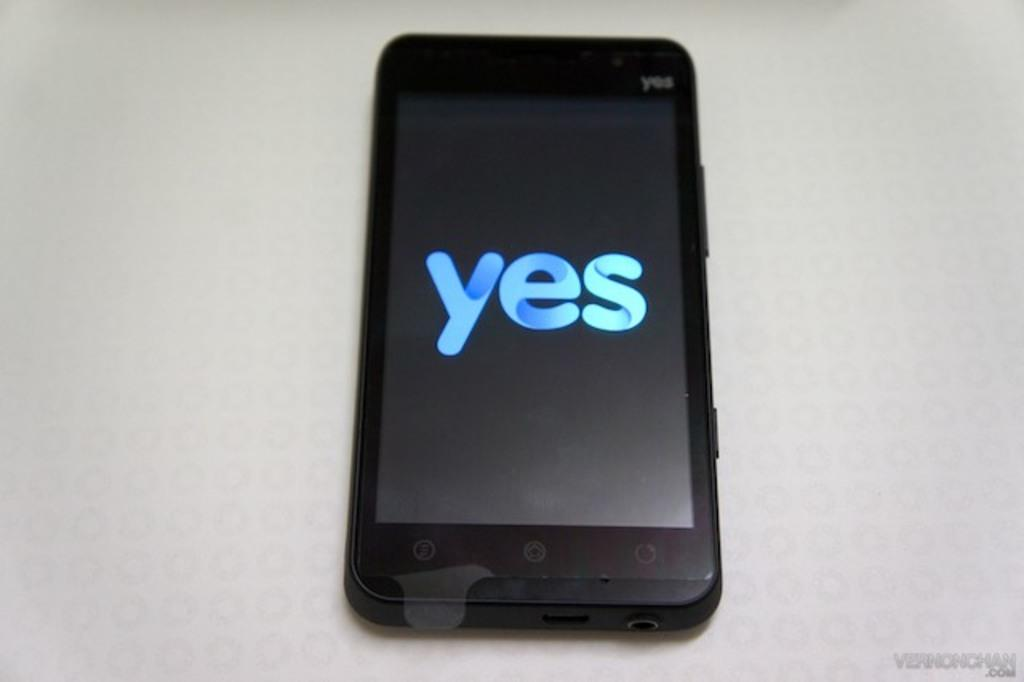<image>
Provide a brief description of the given image. A yes brand cell phone with the display screen reading yes 